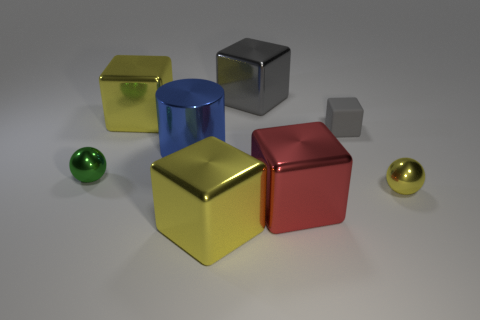Are there fewer small green shiny things that are on the left side of the metal cylinder than tiny green metallic balls that are right of the big gray thing?
Your response must be concise. No. The tiny matte object is what color?
Your answer should be compact. Gray. How many small rubber cubes are the same color as the small matte thing?
Your answer should be very brief. 0. There is a small gray matte thing; are there any green shiny objects on the left side of it?
Keep it short and to the point. Yes. Are there the same number of tiny yellow metallic things in front of the large blue metal thing and yellow shiny cubes in front of the green metallic sphere?
Make the answer very short. Yes. Is the size of the metallic block right of the big gray block the same as the yellow cube in front of the small gray matte cube?
Your answer should be very brief. Yes. There is a tiny metal thing that is to the left of the big yellow object that is right of the yellow cube behind the tiny green shiny object; what is its shape?
Your answer should be compact. Sphere. Is there any other thing that has the same material as the tiny gray block?
Make the answer very short. No. What is the size of the gray matte object that is the same shape as the large red object?
Your response must be concise. Small. There is a thing that is both in front of the tiny yellow ball and left of the large gray shiny object; what is its color?
Your response must be concise. Yellow. 